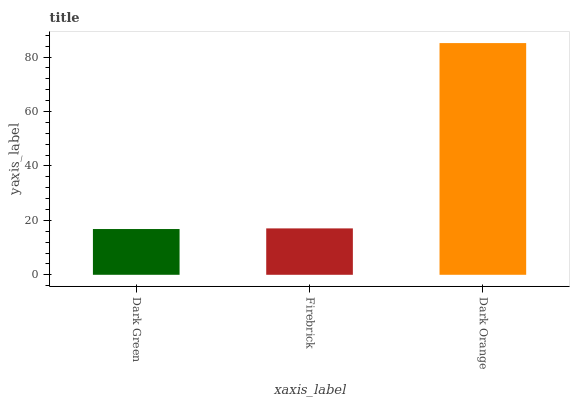Is Dark Green the minimum?
Answer yes or no. Yes. Is Dark Orange the maximum?
Answer yes or no. Yes. Is Firebrick the minimum?
Answer yes or no. No. Is Firebrick the maximum?
Answer yes or no. No. Is Firebrick greater than Dark Green?
Answer yes or no. Yes. Is Dark Green less than Firebrick?
Answer yes or no. Yes. Is Dark Green greater than Firebrick?
Answer yes or no. No. Is Firebrick less than Dark Green?
Answer yes or no. No. Is Firebrick the high median?
Answer yes or no. Yes. Is Firebrick the low median?
Answer yes or no. Yes. Is Dark Orange the high median?
Answer yes or no. No. Is Dark Green the low median?
Answer yes or no. No. 